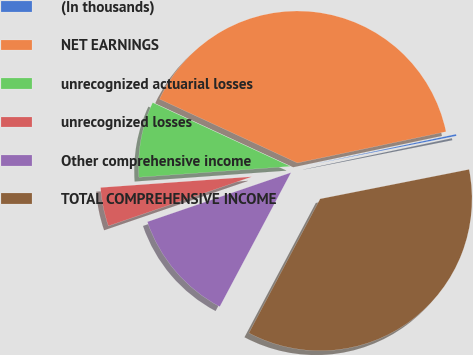<chart> <loc_0><loc_0><loc_500><loc_500><pie_chart><fcel>(In thousands)<fcel>NET EARNINGS<fcel>unrecognized actuarial losses<fcel>unrecognized losses<fcel>Other comprehensive income<fcel>TOTAL COMPREHENSIVE INCOME<nl><fcel>0.19%<fcel>39.8%<fcel>8.04%<fcel>4.12%<fcel>11.97%<fcel>35.88%<nl></chart> 